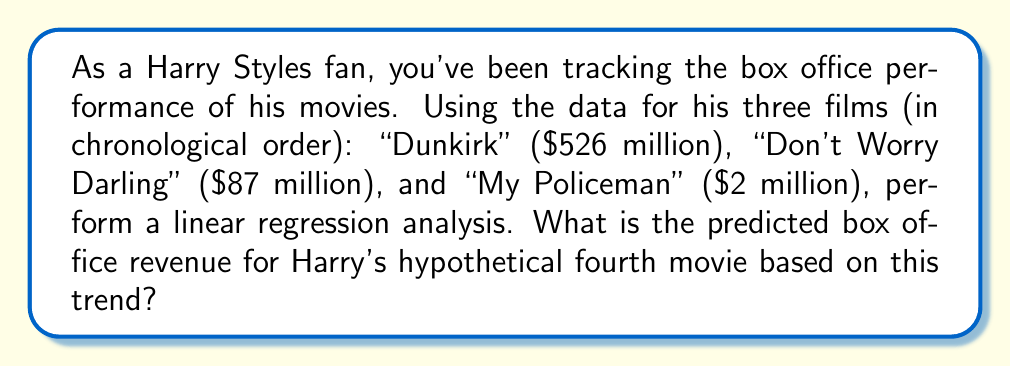Could you help me with this problem? Let's approach this step-by-step using linear regression:

1) Let $x$ represent the movie number (1, 2, 3) and $y$ represent the box office revenue in millions.

2) We have these data points:
   $(1, 526)$, $(2, 87)$, $(3, 2)$

3) To perform linear regression, we'll use the formulas:
   
   $m = \frac{n\sum xy - \sum x \sum y}{n\sum x^2 - (\sum x)^2}$
   
   $b = \frac{\sum y - m\sum x}{n}$

   Where $m$ is the slope and $b$ is the y-intercept.

4) Calculate the sums:
   $\sum x = 1 + 2 + 3 = 6$
   $\sum y = 526 + 87 + 2 = 615$
   $\sum xy = 1(526) + 2(87) + 3(2) = 704$
   $\sum x^2 = 1^2 + 2^2 + 3^2 = 14$
   $n = 3$

5) Calculate $m$:
   $$m = \frac{3(704) - 6(615)}{3(14) - 6^2} = \frac{2112 - 3690}{42 - 36} = \frac{-1578}{6} = -263$$

6) Calculate $b$:
   $$b = \frac{615 - (-263)(6)}{3} = \frac{615 + 1578}{3} = 731$$

7) Our regression line equation is:
   $y = -263x + 731$

8) For the fourth movie, $x = 4$. Let's predict $y$:
   $y = -263(4) + 731 = -321$

However, box office revenue can't be negative. This means our linear model predicts that the trend will hit zero before the fourth movie.
Answer: $0 million (The trend predicts negative revenue, which is impossible for box office earnings) 